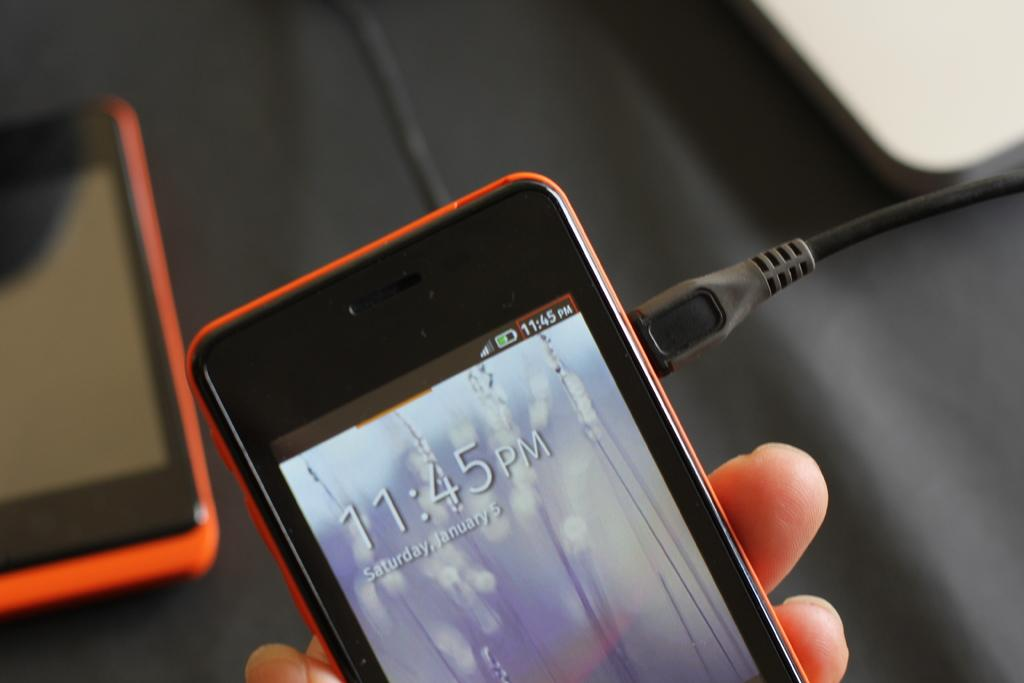<image>
Share a concise interpretation of the image provided. The time is currently 11:45 pm on Saturday, January 5. 